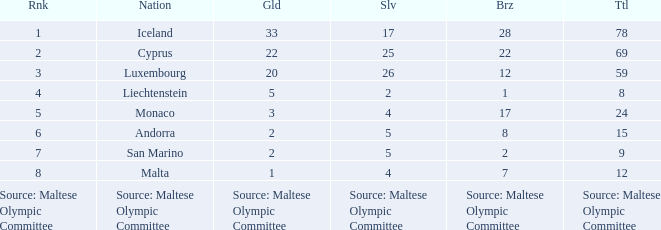What rank is the nation with 2 silver medals? 4.0. 